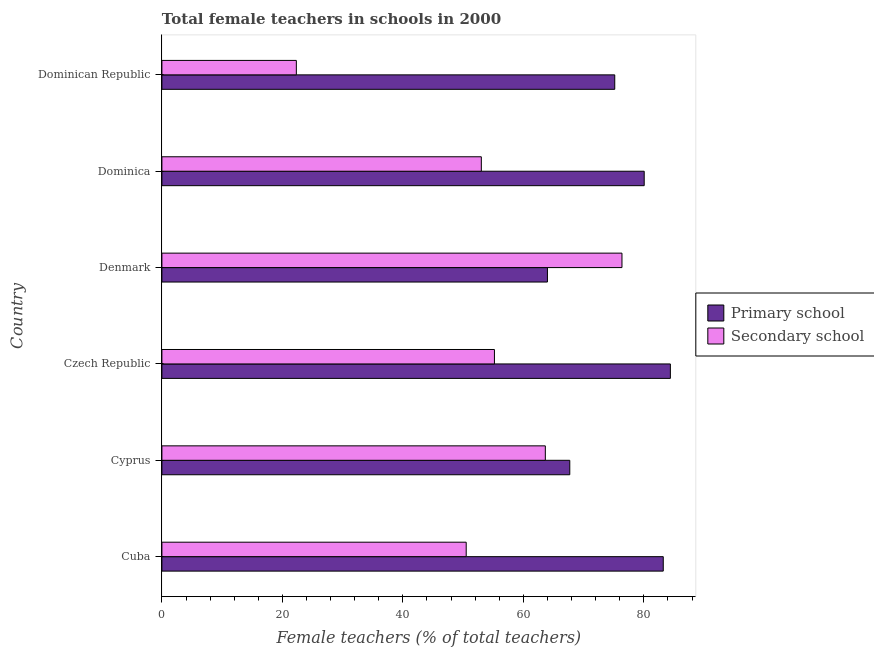How many different coloured bars are there?
Keep it short and to the point. 2. Are the number of bars on each tick of the Y-axis equal?
Offer a terse response. Yes. What is the label of the 5th group of bars from the top?
Your answer should be compact. Cyprus. What is the percentage of female teachers in secondary schools in Denmark?
Your response must be concise. 76.38. Across all countries, what is the maximum percentage of female teachers in secondary schools?
Your answer should be compact. 76.38. Across all countries, what is the minimum percentage of female teachers in secondary schools?
Ensure brevity in your answer.  22.32. In which country was the percentage of female teachers in secondary schools maximum?
Give a very brief answer. Denmark. In which country was the percentage of female teachers in primary schools minimum?
Your response must be concise. Denmark. What is the total percentage of female teachers in secondary schools in the graph?
Offer a terse response. 321.1. What is the difference between the percentage of female teachers in primary schools in Cyprus and that in Dominican Republic?
Your answer should be very brief. -7.47. What is the difference between the percentage of female teachers in primary schools in Czech Republic and the percentage of female teachers in secondary schools in Cyprus?
Keep it short and to the point. 20.76. What is the average percentage of female teachers in primary schools per country?
Make the answer very short. 75.77. What is the difference between the percentage of female teachers in primary schools and percentage of female teachers in secondary schools in Cyprus?
Your response must be concise. 4.06. In how many countries, is the percentage of female teachers in secondary schools greater than 72 %?
Ensure brevity in your answer.  1. What is the ratio of the percentage of female teachers in secondary schools in Czech Republic to that in Dominica?
Provide a short and direct response. 1.04. What is the difference between the highest and the second highest percentage of female teachers in secondary schools?
Ensure brevity in your answer.  12.72. What is the difference between the highest and the lowest percentage of female teachers in secondary schools?
Your answer should be very brief. 54.06. Is the sum of the percentage of female teachers in primary schools in Cyprus and Dominican Republic greater than the maximum percentage of female teachers in secondary schools across all countries?
Give a very brief answer. Yes. What does the 1st bar from the top in Denmark represents?
Ensure brevity in your answer.  Secondary school. What does the 1st bar from the bottom in Dominica represents?
Your answer should be compact. Primary school. How many bars are there?
Your answer should be very brief. 12. Are the values on the major ticks of X-axis written in scientific E-notation?
Your answer should be compact. No. Does the graph contain any zero values?
Offer a terse response. No. Does the graph contain grids?
Make the answer very short. No. Where does the legend appear in the graph?
Give a very brief answer. Center right. How are the legend labels stacked?
Your answer should be compact. Vertical. What is the title of the graph?
Provide a short and direct response. Total female teachers in schools in 2000. What is the label or title of the X-axis?
Keep it short and to the point. Female teachers (% of total teachers). What is the label or title of the Y-axis?
Provide a short and direct response. Country. What is the Female teachers (% of total teachers) in Primary school in Cuba?
Offer a terse response. 83.23. What is the Female teachers (% of total teachers) of Secondary school in Cuba?
Make the answer very short. 50.52. What is the Female teachers (% of total teachers) in Primary school in Cyprus?
Provide a succinct answer. 67.71. What is the Female teachers (% of total teachers) of Secondary school in Cyprus?
Your response must be concise. 63.65. What is the Female teachers (% of total teachers) in Primary school in Czech Republic?
Your answer should be compact. 84.41. What is the Female teachers (% of total teachers) in Secondary school in Czech Republic?
Ensure brevity in your answer.  55.2. What is the Female teachers (% of total teachers) in Primary school in Denmark?
Your answer should be very brief. 64. What is the Female teachers (% of total teachers) of Secondary school in Denmark?
Offer a terse response. 76.38. What is the Female teachers (% of total teachers) of Primary school in Dominica?
Keep it short and to the point. 80.07. What is the Female teachers (% of total teachers) in Secondary school in Dominica?
Make the answer very short. 53.03. What is the Female teachers (% of total teachers) in Primary school in Dominican Republic?
Provide a short and direct response. 75.18. What is the Female teachers (% of total teachers) in Secondary school in Dominican Republic?
Provide a short and direct response. 22.32. Across all countries, what is the maximum Female teachers (% of total teachers) of Primary school?
Keep it short and to the point. 84.41. Across all countries, what is the maximum Female teachers (% of total teachers) of Secondary school?
Your response must be concise. 76.38. Across all countries, what is the minimum Female teachers (% of total teachers) of Primary school?
Your response must be concise. 64. Across all countries, what is the minimum Female teachers (% of total teachers) in Secondary school?
Offer a terse response. 22.32. What is the total Female teachers (% of total teachers) of Primary school in the graph?
Your answer should be very brief. 454.6. What is the total Female teachers (% of total teachers) in Secondary school in the graph?
Ensure brevity in your answer.  321.1. What is the difference between the Female teachers (% of total teachers) in Primary school in Cuba and that in Cyprus?
Your response must be concise. 15.52. What is the difference between the Female teachers (% of total teachers) in Secondary school in Cuba and that in Cyprus?
Provide a succinct answer. -13.14. What is the difference between the Female teachers (% of total teachers) of Primary school in Cuba and that in Czech Republic?
Provide a short and direct response. -1.18. What is the difference between the Female teachers (% of total teachers) of Secondary school in Cuba and that in Czech Republic?
Your response must be concise. -4.69. What is the difference between the Female teachers (% of total teachers) of Primary school in Cuba and that in Denmark?
Offer a very short reply. 19.23. What is the difference between the Female teachers (% of total teachers) in Secondary school in Cuba and that in Denmark?
Offer a very short reply. -25.86. What is the difference between the Female teachers (% of total teachers) of Primary school in Cuba and that in Dominica?
Ensure brevity in your answer.  3.16. What is the difference between the Female teachers (% of total teachers) of Secondary school in Cuba and that in Dominica?
Your response must be concise. -2.51. What is the difference between the Female teachers (% of total teachers) of Primary school in Cuba and that in Dominican Republic?
Your answer should be compact. 8.05. What is the difference between the Female teachers (% of total teachers) in Secondary school in Cuba and that in Dominican Republic?
Provide a succinct answer. 28.2. What is the difference between the Female teachers (% of total teachers) in Primary school in Cyprus and that in Czech Republic?
Offer a terse response. -16.7. What is the difference between the Female teachers (% of total teachers) of Secondary school in Cyprus and that in Czech Republic?
Your response must be concise. 8.45. What is the difference between the Female teachers (% of total teachers) in Primary school in Cyprus and that in Denmark?
Ensure brevity in your answer.  3.71. What is the difference between the Female teachers (% of total teachers) in Secondary school in Cyprus and that in Denmark?
Your answer should be very brief. -12.72. What is the difference between the Female teachers (% of total teachers) in Primary school in Cyprus and that in Dominica?
Give a very brief answer. -12.36. What is the difference between the Female teachers (% of total teachers) of Secondary school in Cyprus and that in Dominica?
Offer a very short reply. 10.62. What is the difference between the Female teachers (% of total teachers) in Primary school in Cyprus and that in Dominican Republic?
Your answer should be compact. -7.47. What is the difference between the Female teachers (% of total teachers) of Secondary school in Cyprus and that in Dominican Republic?
Your response must be concise. 41.33. What is the difference between the Female teachers (% of total teachers) in Primary school in Czech Republic and that in Denmark?
Keep it short and to the point. 20.41. What is the difference between the Female teachers (% of total teachers) of Secondary school in Czech Republic and that in Denmark?
Offer a terse response. -21.17. What is the difference between the Female teachers (% of total teachers) of Primary school in Czech Republic and that in Dominica?
Keep it short and to the point. 4.35. What is the difference between the Female teachers (% of total teachers) in Secondary school in Czech Republic and that in Dominica?
Your answer should be compact. 2.18. What is the difference between the Female teachers (% of total teachers) in Primary school in Czech Republic and that in Dominican Republic?
Ensure brevity in your answer.  9.23. What is the difference between the Female teachers (% of total teachers) in Secondary school in Czech Republic and that in Dominican Republic?
Keep it short and to the point. 32.89. What is the difference between the Female teachers (% of total teachers) of Primary school in Denmark and that in Dominica?
Your response must be concise. -16.06. What is the difference between the Female teachers (% of total teachers) in Secondary school in Denmark and that in Dominica?
Offer a terse response. 23.35. What is the difference between the Female teachers (% of total teachers) of Primary school in Denmark and that in Dominican Republic?
Give a very brief answer. -11.18. What is the difference between the Female teachers (% of total teachers) in Secondary school in Denmark and that in Dominican Republic?
Provide a short and direct response. 54.06. What is the difference between the Female teachers (% of total teachers) of Primary school in Dominica and that in Dominican Republic?
Ensure brevity in your answer.  4.89. What is the difference between the Female teachers (% of total teachers) in Secondary school in Dominica and that in Dominican Republic?
Your response must be concise. 30.71. What is the difference between the Female teachers (% of total teachers) in Primary school in Cuba and the Female teachers (% of total teachers) in Secondary school in Cyprus?
Provide a short and direct response. 19.58. What is the difference between the Female teachers (% of total teachers) of Primary school in Cuba and the Female teachers (% of total teachers) of Secondary school in Czech Republic?
Offer a very short reply. 28.03. What is the difference between the Female teachers (% of total teachers) of Primary school in Cuba and the Female teachers (% of total teachers) of Secondary school in Denmark?
Keep it short and to the point. 6.85. What is the difference between the Female teachers (% of total teachers) in Primary school in Cuba and the Female teachers (% of total teachers) in Secondary school in Dominica?
Keep it short and to the point. 30.2. What is the difference between the Female teachers (% of total teachers) in Primary school in Cuba and the Female teachers (% of total teachers) in Secondary school in Dominican Republic?
Keep it short and to the point. 60.91. What is the difference between the Female teachers (% of total teachers) of Primary school in Cyprus and the Female teachers (% of total teachers) of Secondary school in Czech Republic?
Your response must be concise. 12.51. What is the difference between the Female teachers (% of total teachers) of Primary school in Cyprus and the Female teachers (% of total teachers) of Secondary school in Denmark?
Provide a short and direct response. -8.67. What is the difference between the Female teachers (% of total teachers) in Primary school in Cyprus and the Female teachers (% of total teachers) in Secondary school in Dominica?
Offer a terse response. 14.68. What is the difference between the Female teachers (% of total teachers) in Primary school in Cyprus and the Female teachers (% of total teachers) in Secondary school in Dominican Republic?
Your answer should be very brief. 45.39. What is the difference between the Female teachers (% of total teachers) of Primary school in Czech Republic and the Female teachers (% of total teachers) of Secondary school in Denmark?
Your answer should be compact. 8.04. What is the difference between the Female teachers (% of total teachers) of Primary school in Czech Republic and the Female teachers (% of total teachers) of Secondary school in Dominica?
Your answer should be compact. 31.38. What is the difference between the Female teachers (% of total teachers) of Primary school in Czech Republic and the Female teachers (% of total teachers) of Secondary school in Dominican Republic?
Offer a very short reply. 62.09. What is the difference between the Female teachers (% of total teachers) of Primary school in Denmark and the Female teachers (% of total teachers) of Secondary school in Dominica?
Keep it short and to the point. 10.97. What is the difference between the Female teachers (% of total teachers) of Primary school in Denmark and the Female teachers (% of total teachers) of Secondary school in Dominican Republic?
Your answer should be very brief. 41.68. What is the difference between the Female teachers (% of total teachers) of Primary school in Dominica and the Female teachers (% of total teachers) of Secondary school in Dominican Republic?
Keep it short and to the point. 57.75. What is the average Female teachers (% of total teachers) in Primary school per country?
Offer a very short reply. 75.77. What is the average Female teachers (% of total teachers) of Secondary school per country?
Make the answer very short. 53.52. What is the difference between the Female teachers (% of total teachers) of Primary school and Female teachers (% of total teachers) of Secondary school in Cuba?
Keep it short and to the point. 32.71. What is the difference between the Female teachers (% of total teachers) of Primary school and Female teachers (% of total teachers) of Secondary school in Cyprus?
Your answer should be compact. 4.06. What is the difference between the Female teachers (% of total teachers) in Primary school and Female teachers (% of total teachers) in Secondary school in Czech Republic?
Offer a terse response. 29.21. What is the difference between the Female teachers (% of total teachers) of Primary school and Female teachers (% of total teachers) of Secondary school in Denmark?
Provide a short and direct response. -12.37. What is the difference between the Female teachers (% of total teachers) of Primary school and Female teachers (% of total teachers) of Secondary school in Dominica?
Offer a very short reply. 27.04. What is the difference between the Female teachers (% of total teachers) of Primary school and Female teachers (% of total teachers) of Secondary school in Dominican Republic?
Make the answer very short. 52.86. What is the ratio of the Female teachers (% of total teachers) in Primary school in Cuba to that in Cyprus?
Your response must be concise. 1.23. What is the ratio of the Female teachers (% of total teachers) of Secondary school in Cuba to that in Cyprus?
Your response must be concise. 0.79. What is the ratio of the Female teachers (% of total teachers) in Secondary school in Cuba to that in Czech Republic?
Ensure brevity in your answer.  0.92. What is the ratio of the Female teachers (% of total teachers) in Primary school in Cuba to that in Denmark?
Offer a terse response. 1.3. What is the ratio of the Female teachers (% of total teachers) in Secondary school in Cuba to that in Denmark?
Provide a short and direct response. 0.66. What is the ratio of the Female teachers (% of total teachers) in Primary school in Cuba to that in Dominica?
Ensure brevity in your answer.  1.04. What is the ratio of the Female teachers (% of total teachers) of Secondary school in Cuba to that in Dominica?
Provide a short and direct response. 0.95. What is the ratio of the Female teachers (% of total teachers) of Primary school in Cuba to that in Dominican Republic?
Provide a succinct answer. 1.11. What is the ratio of the Female teachers (% of total teachers) in Secondary school in Cuba to that in Dominican Republic?
Give a very brief answer. 2.26. What is the ratio of the Female teachers (% of total teachers) in Primary school in Cyprus to that in Czech Republic?
Provide a succinct answer. 0.8. What is the ratio of the Female teachers (% of total teachers) of Secondary school in Cyprus to that in Czech Republic?
Your response must be concise. 1.15. What is the ratio of the Female teachers (% of total teachers) of Primary school in Cyprus to that in Denmark?
Provide a succinct answer. 1.06. What is the ratio of the Female teachers (% of total teachers) of Secondary school in Cyprus to that in Denmark?
Keep it short and to the point. 0.83. What is the ratio of the Female teachers (% of total teachers) in Primary school in Cyprus to that in Dominica?
Provide a short and direct response. 0.85. What is the ratio of the Female teachers (% of total teachers) in Secondary school in Cyprus to that in Dominica?
Your answer should be very brief. 1.2. What is the ratio of the Female teachers (% of total teachers) of Primary school in Cyprus to that in Dominican Republic?
Provide a succinct answer. 0.9. What is the ratio of the Female teachers (% of total teachers) in Secondary school in Cyprus to that in Dominican Republic?
Make the answer very short. 2.85. What is the ratio of the Female teachers (% of total teachers) of Primary school in Czech Republic to that in Denmark?
Provide a short and direct response. 1.32. What is the ratio of the Female teachers (% of total teachers) in Secondary school in Czech Republic to that in Denmark?
Keep it short and to the point. 0.72. What is the ratio of the Female teachers (% of total teachers) of Primary school in Czech Republic to that in Dominica?
Give a very brief answer. 1.05. What is the ratio of the Female teachers (% of total teachers) of Secondary school in Czech Republic to that in Dominica?
Make the answer very short. 1.04. What is the ratio of the Female teachers (% of total teachers) in Primary school in Czech Republic to that in Dominican Republic?
Offer a terse response. 1.12. What is the ratio of the Female teachers (% of total teachers) in Secondary school in Czech Republic to that in Dominican Republic?
Provide a short and direct response. 2.47. What is the ratio of the Female teachers (% of total teachers) of Primary school in Denmark to that in Dominica?
Ensure brevity in your answer.  0.8. What is the ratio of the Female teachers (% of total teachers) of Secondary school in Denmark to that in Dominica?
Keep it short and to the point. 1.44. What is the ratio of the Female teachers (% of total teachers) in Primary school in Denmark to that in Dominican Republic?
Your response must be concise. 0.85. What is the ratio of the Female teachers (% of total teachers) of Secondary school in Denmark to that in Dominican Republic?
Provide a succinct answer. 3.42. What is the ratio of the Female teachers (% of total teachers) of Primary school in Dominica to that in Dominican Republic?
Give a very brief answer. 1.06. What is the ratio of the Female teachers (% of total teachers) of Secondary school in Dominica to that in Dominican Republic?
Provide a succinct answer. 2.38. What is the difference between the highest and the second highest Female teachers (% of total teachers) of Primary school?
Offer a very short reply. 1.18. What is the difference between the highest and the second highest Female teachers (% of total teachers) in Secondary school?
Provide a short and direct response. 12.72. What is the difference between the highest and the lowest Female teachers (% of total teachers) in Primary school?
Offer a terse response. 20.41. What is the difference between the highest and the lowest Female teachers (% of total teachers) of Secondary school?
Give a very brief answer. 54.06. 